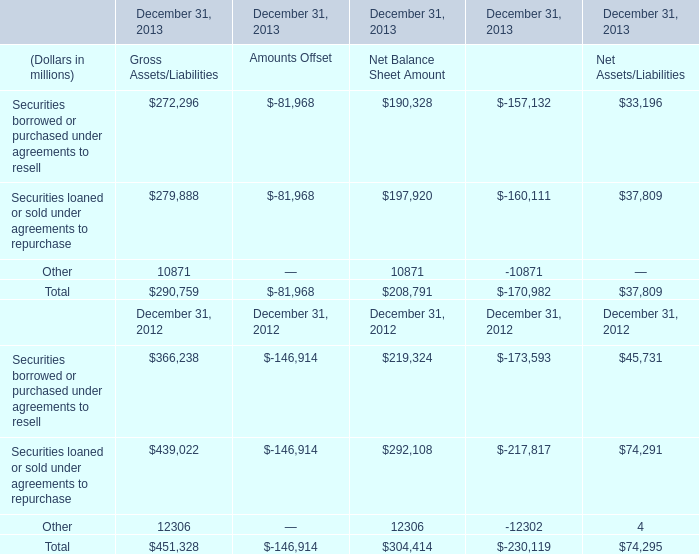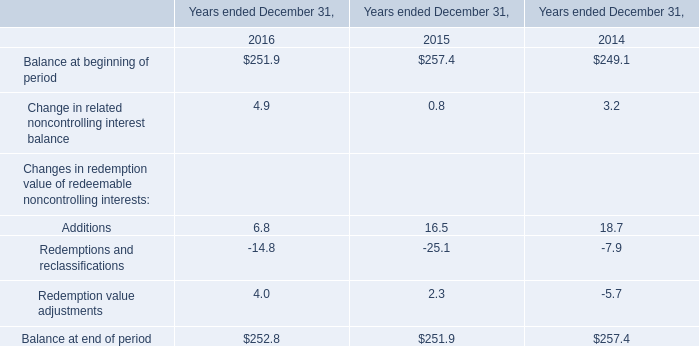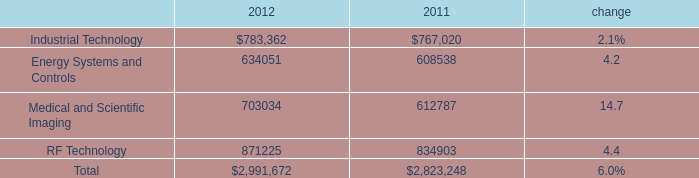What is the average amount of Securities borrowed or purchased under agreements to resell for Gross Assets/Liabilities between 2012 and 2013? (in million) 
Computations: ((272296 + 366238) / 2)
Answer: 319267.0. 